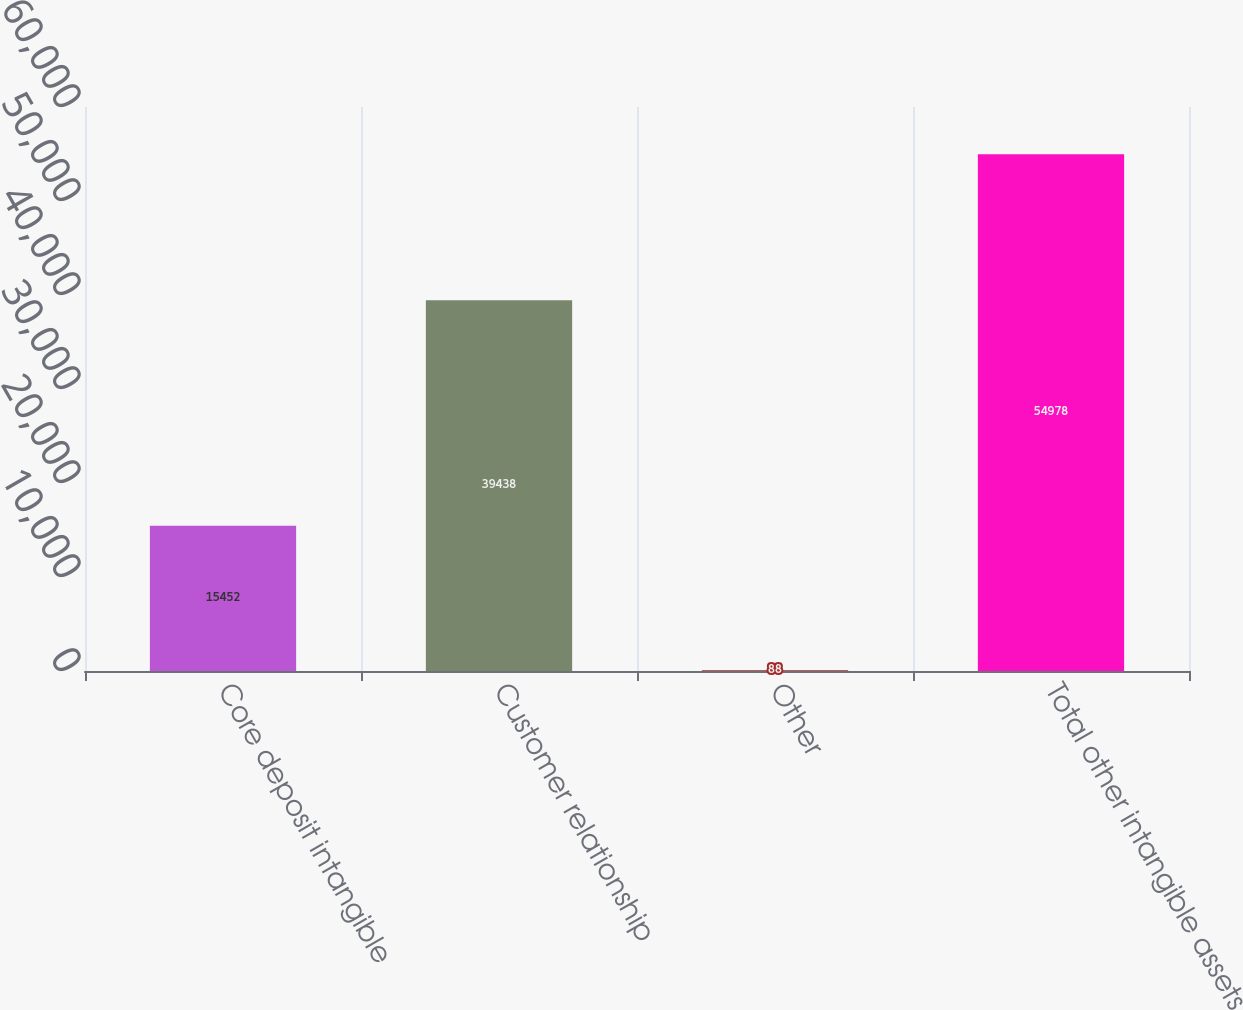Convert chart to OTSL. <chart><loc_0><loc_0><loc_500><loc_500><bar_chart><fcel>Core deposit intangible<fcel>Customer relationship<fcel>Other<fcel>Total other intangible assets<nl><fcel>15452<fcel>39438<fcel>88<fcel>54978<nl></chart> 